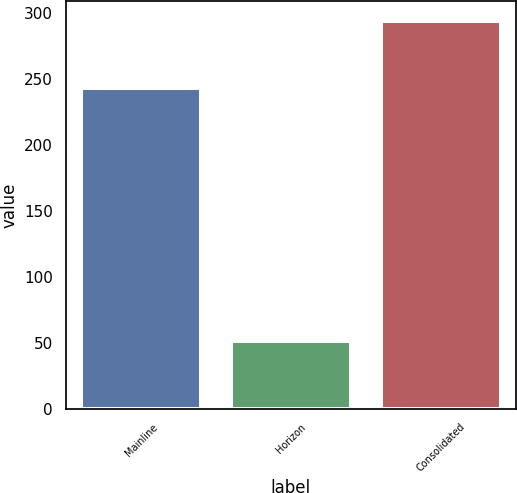Convert chart. <chart><loc_0><loc_0><loc_500><loc_500><bar_chart><fcel>Mainline<fcel>Horizon<fcel>Consolidated<nl><fcel>243<fcel>51<fcel>294<nl></chart> 